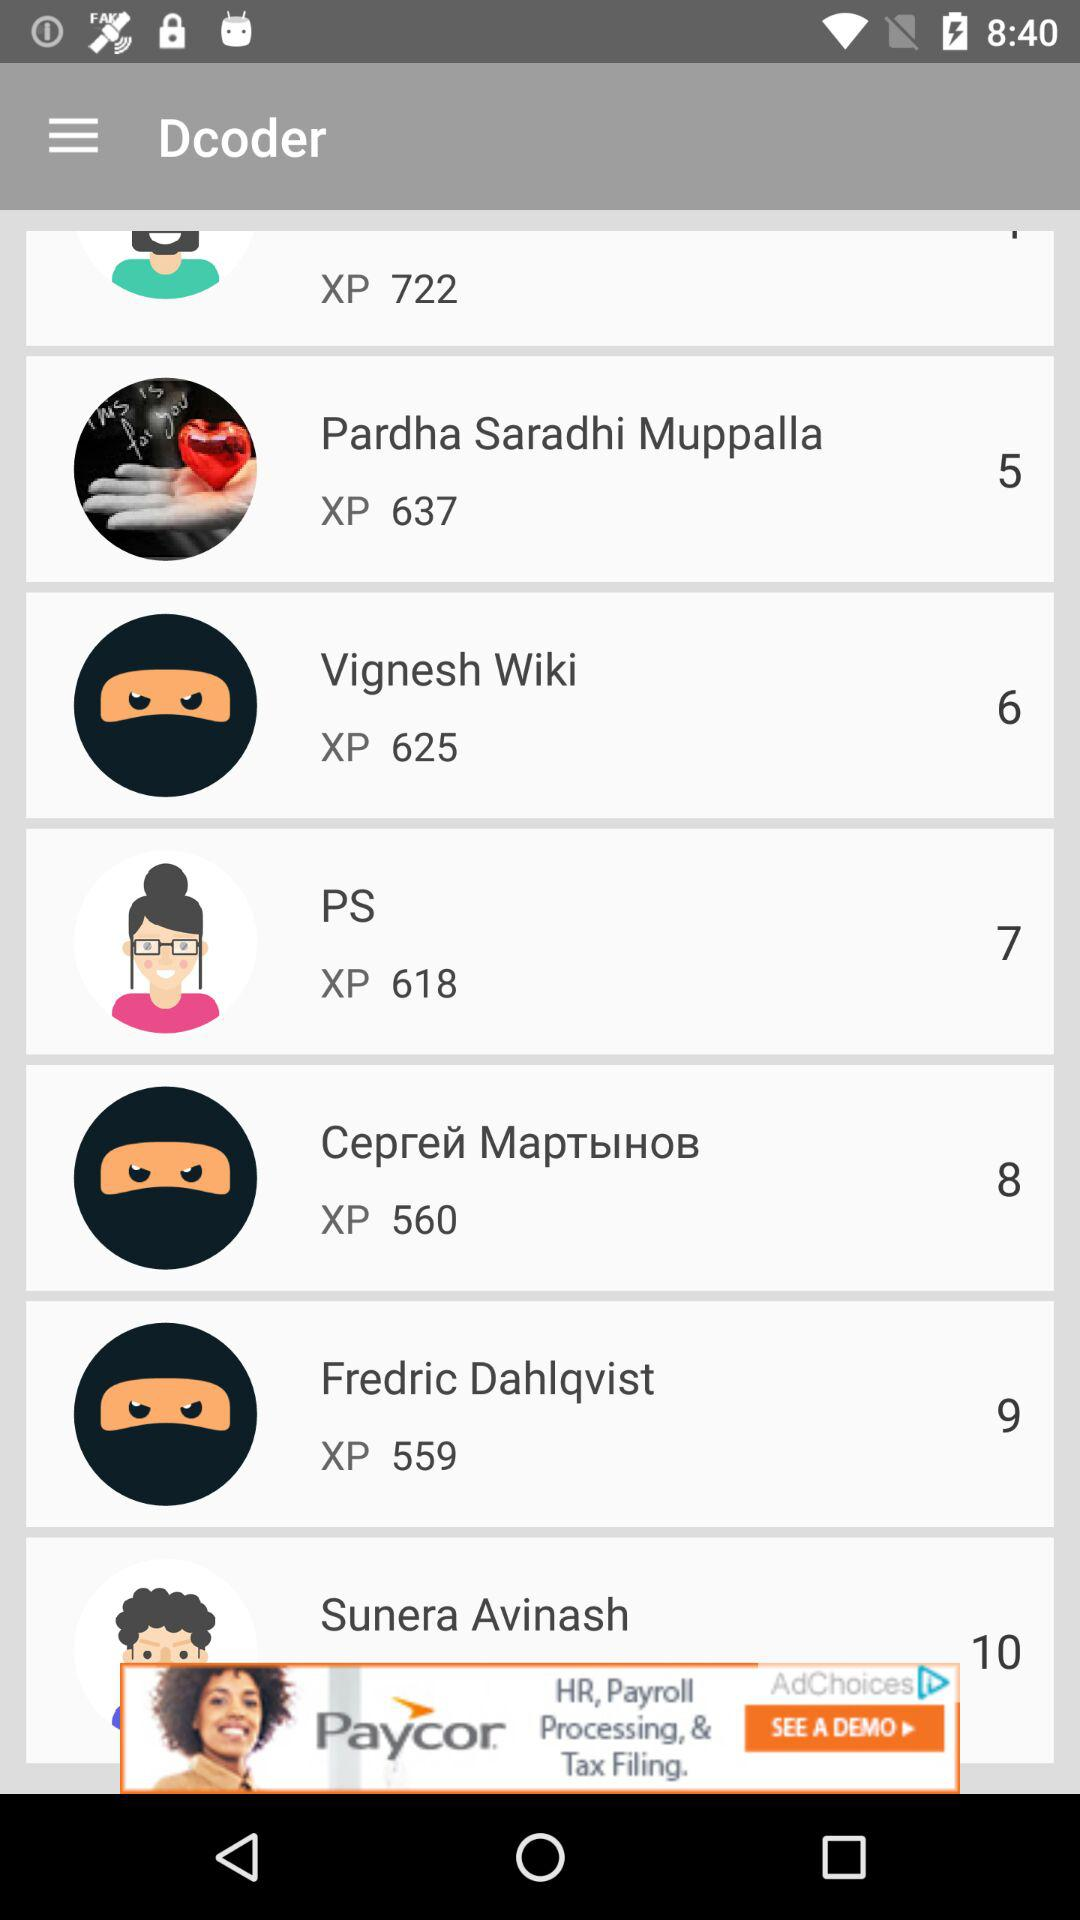How much XP did PS get? PS got 618 XP. 